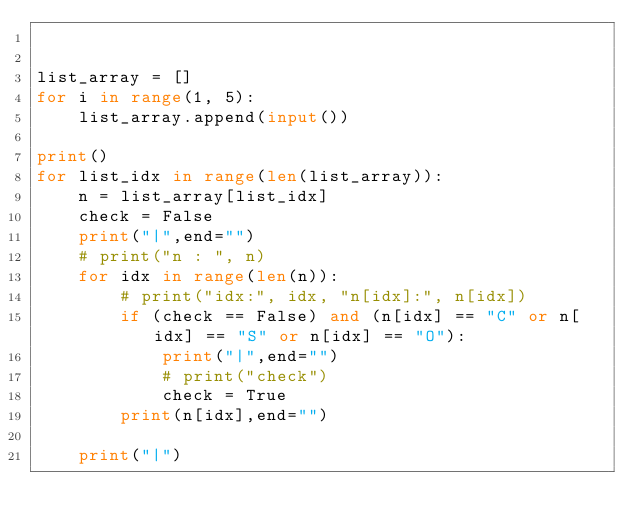Convert code to text. <code><loc_0><loc_0><loc_500><loc_500><_Python_>

list_array = []
for i in range(1, 5):
    list_array.append(input())

print()
for list_idx in range(len(list_array)):
    n = list_array[list_idx]
    check = False
    print("|",end="")
    # print("n : ", n)
    for idx in range(len(n)):
        # print("idx:", idx, "n[idx]:", n[idx])
        if (check == False) and (n[idx] == "C" or n[idx] == "S" or n[idx] == "O"):
            print("|",end="")
            # print("check")
            check = True
        print(n[idx],end="")

    print("|")

</code> 